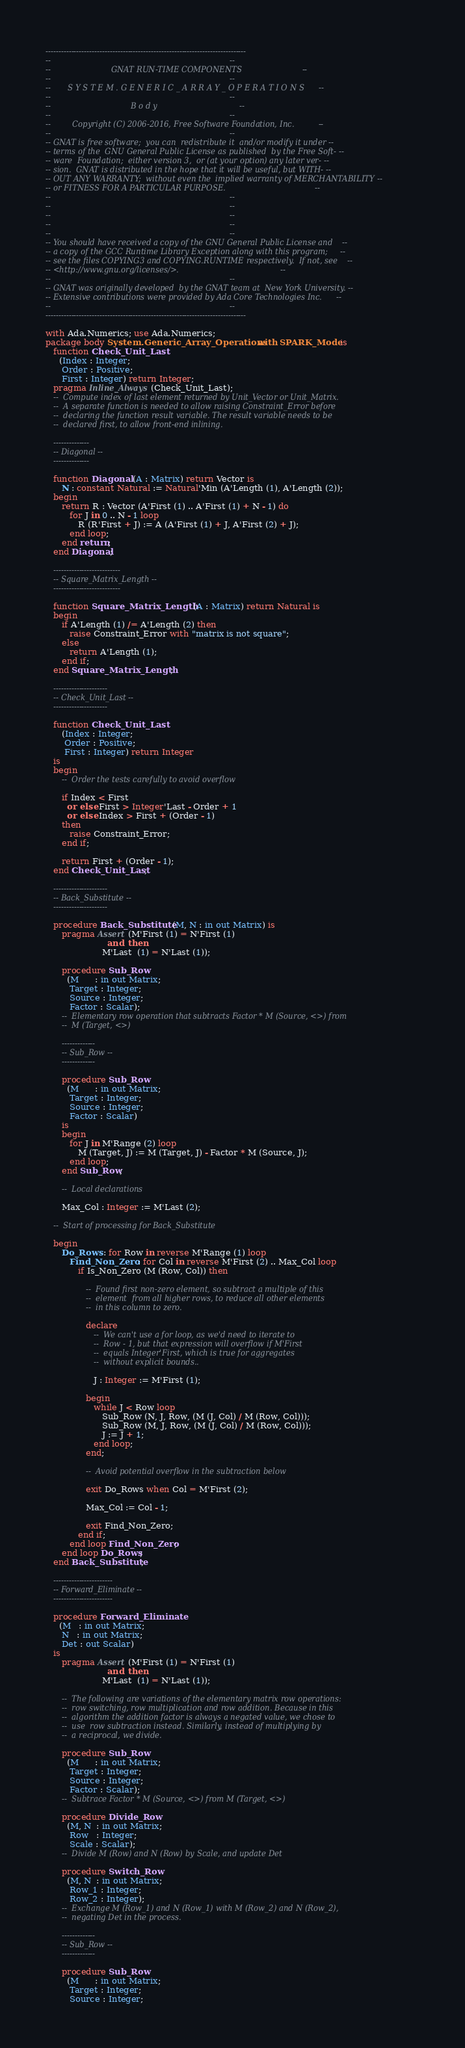<code> <loc_0><loc_0><loc_500><loc_500><_Ada_>------------------------------------------------------------------------------
--                                                                          --
--                         GNAT RUN-TIME COMPONENTS                         --
--                                                                          --
--       S Y S T E M . G E N E R I C _ A R R A Y _ O P E R A T I O N S      --
--                                                                          --
--                                 B o d y                                  --
--                                                                          --
--         Copyright (C) 2006-2016, Free Software Foundation, Inc.          --
--                                                                          --
-- GNAT is free software;  you can  redistribute it  and/or modify it under --
-- terms of the  GNU General Public License as published  by the Free Soft- --
-- ware  Foundation;  either version 3,  or (at your option) any later ver- --
-- sion.  GNAT is distributed in the hope that it will be useful, but WITH- --
-- OUT ANY WARRANTY;  without even the  implied warranty of MERCHANTABILITY --
-- or FITNESS FOR A PARTICULAR PURPOSE.                                     --
--                                                                          --
--                                                                          --
--                                                                          --
--                                                                          --
--                                                                          --
-- You should have received a copy of the GNU General Public License and    --
-- a copy of the GCC Runtime Library Exception along with this program;     --
-- see the files COPYING3 and COPYING.RUNTIME respectively.  If not, see    --
-- <http://www.gnu.org/licenses/>.                                          --
--                                                                          --
-- GNAT was originally developed  by the GNAT team at  New York University. --
-- Extensive contributions were provided by Ada Core Technologies Inc.      --
--                                                                          --
------------------------------------------------------------------------------

with Ada.Numerics; use Ada.Numerics;
package body System.Generic_Array_Operations with SPARK_Mode is
   function Check_Unit_Last
     (Index : Integer;
      Order : Positive;
      First : Integer) return Integer;
   pragma Inline_Always (Check_Unit_Last);
   --  Compute index of last element returned by Unit_Vector or Unit_Matrix.
   --  A separate function is needed to allow raising Constraint_Error before
   --  declaring the function result variable. The result variable needs to be
   --  declared first, to allow front-end inlining.

   --------------
   -- Diagonal --
   --------------

   function Diagonal (A : Matrix) return Vector is
      N : constant Natural := Natural'Min (A'Length (1), A'Length (2));
   begin
      return R : Vector (A'First (1) .. A'First (1) + N - 1) do
         for J in 0 .. N - 1 loop
            R (R'First + J) := A (A'First (1) + J, A'First (2) + J);
         end loop;
      end return;
   end Diagonal;

   --------------------------
   -- Square_Matrix_Length --
   --------------------------

   function Square_Matrix_Length (A : Matrix) return Natural is
   begin
      if A'Length (1) /= A'Length (2) then
         raise Constraint_Error with "matrix is not square";
      else
         return A'Length (1);
      end if;
   end Square_Matrix_Length;

   ---------------------
   -- Check_Unit_Last --
   ---------------------

   function Check_Unit_Last
      (Index : Integer;
       Order : Positive;
       First : Integer) return Integer
   is
   begin
      --  Order the tests carefully to avoid overflow

      if Index < First
        or else First > Integer'Last - Order + 1
        or else Index > First + (Order - 1)
      then
         raise Constraint_Error;
      end if;

      return First + (Order - 1);
   end Check_Unit_Last;

   ---------------------
   -- Back_Substitute --
   ---------------------

   procedure Back_Substitute (M, N : in out Matrix) is
      pragma Assert (M'First (1) = N'First (1)
                       and then
                     M'Last  (1) = N'Last (1));

      procedure Sub_Row
        (M      : in out Matrix;
         Target : Integer;
         Source : Integer;
         Factor : Scalar);
      --  Elementary row operation that subtracts Factor * M (Source, <>) from
      --  M (Target, <>)

      -------------
      -- Sub_Row --
      -------------

      procedure Sub_Row
        (M      : in out Matrix;
         Target : Integer;
         Source : Integer;
         Factor : Scalar)
      is
      begin
         for J in M'Range (2) loop
            M (Target, J) := M (Target, J) - Factor * M (Source, J);
         end loop;
      end Sub_Row;

      --  Local declarations

      Max_Col : Integer := M'Last (2);

   --  Start of processing for Back_Substitute

   begin
      Do_Rows : for Row in reverse M'Range (1) loop
         Find_Non_Zero : for Col in reverse M'First (2) .. Max_Col loop
            if Is_Non_Zero (M (Row, Col)) then

               --  Found first non-zero element, so subtract a multiple of this
               --  element  from all higher rows, to reduce all other elements
               --  in this column to zero.

               declare
                  --  We can't use a for loop, as we'd need to iterate to
                  --  Row - 1, but that expression will overflow if M'First
                  --  equals Integer'First, which is true for aggregates
                  --  without explicit bounds..

                  J : Integer := M'First (1);

               begin
                  while J < Row loop
                     Sub_Row (N, J, Row, (M (J, Col) / M (Row, Col)));
                     Sub_Row (M, J, Row, (M (J, Col) / M (Row, Col)));
                     J := J + 1;
                  end loop;
               end;

               --  Avoid potential overflow in the subtraction below

               exit Do_Rows when Col = M'First (2);

               Max_Col := Col - 1;

               exit Find_Non_Zero;
            end if;
         end loop Find_Non_Zero;
      end loop Do_Rows;
   end Back_Substitute;

   -----------------------
   -- Forward_Eliminate --
   -----------------------

   procedure Forward_Eliminate
     (M   : in out Matrix;
      N   : in out Matrix;
      Det : out Scalar)
   is
      pragma Assert (M'First (1) = N'First (1)
                       and then
                     M'Last  (1) = N'Last (1));

      --  The following are variations of the elementary matrix row operations:
      --  row switching, row multiplication and row addition. Because in this
      --  algorithm the addition factor is always a negated value, we chose to
      --  use  row subtraction instead. Similarly, instead of multiplying by
      --  a reciprocal, we divide.

      procedure Sub_Row
        (M      : in out Matrix;
         Target : Integer;
         Source : Integer;
         Factor : Scalar);
      --  Subtrace Factor * M (Source, <>) from M (Target, <>)

      procedure Divide_Row
        (M, N  : in out Matrix;
         Row   : Integer;
         Scale : Scalar);
      --  Divide M (Row) and N (Row) by Scale, and update Det

      procedure Switch_Row
        (M, N  : in out Matrix;
         Row_1 : Integer;
         Row_2 : Integer);
      --  Exchange M (Row_1) and N (Row_1) with M (Row_2) and N (Row_2),
      --  negating Det in the process.

      -------------
      -- Sub_Row --
      -------------

      procedure Sub_Row
        (M      : in out Matrix;
         Target : Integer;
         Source : Integer;</code> 